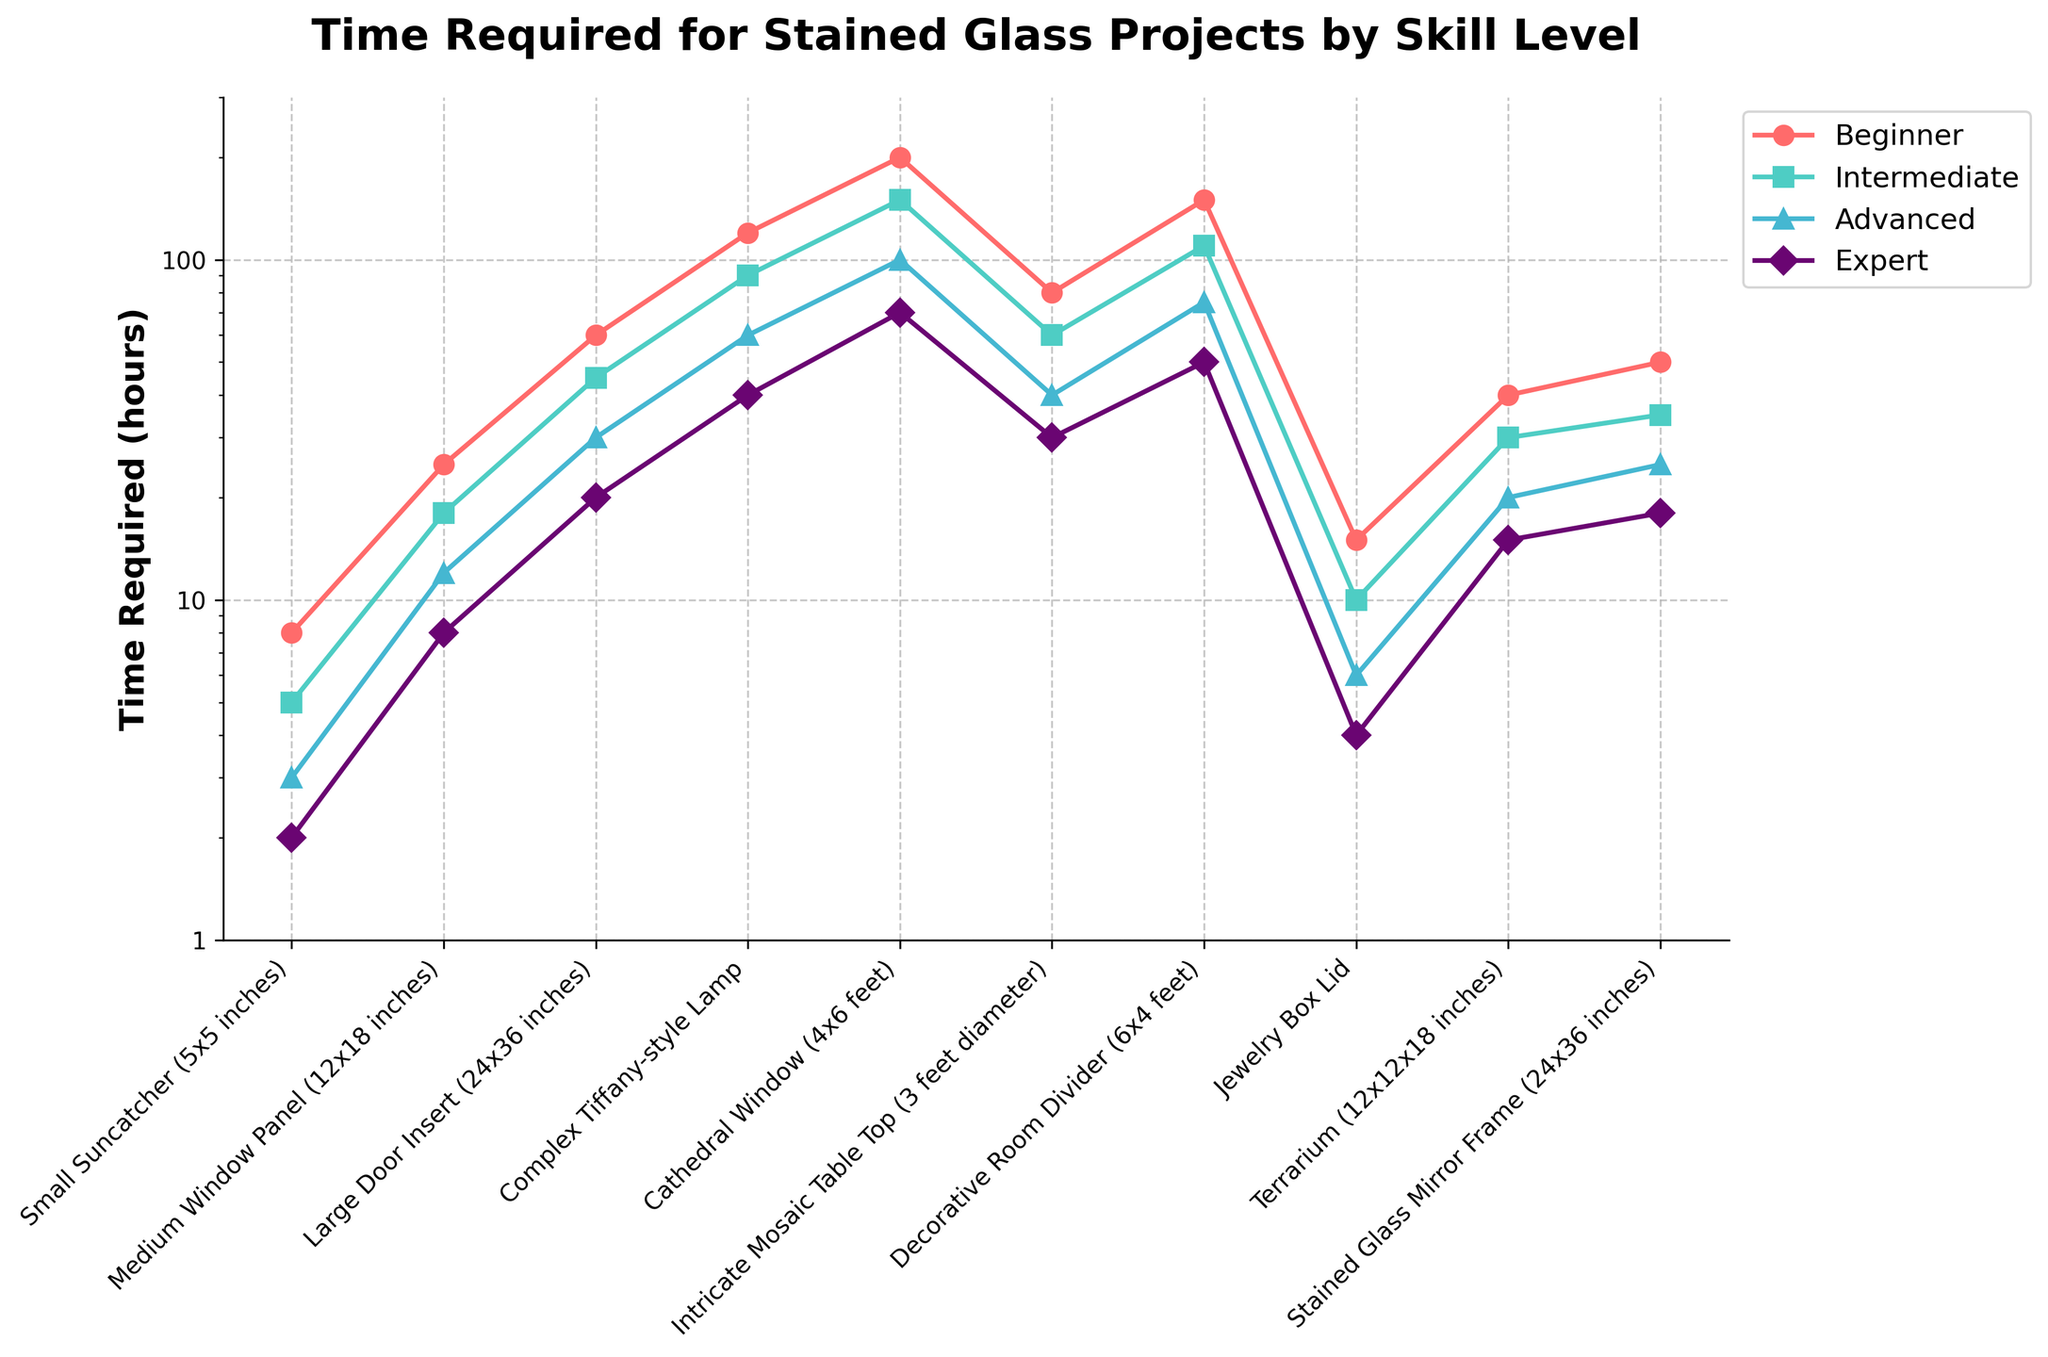What is the difference in time required between a Beginner and an Expert for a Complex Tiffany-style Lamp project? The figure shows the time required for a Complex Tiffany-style Lamp project is 120 hours for a Beginner and 40 hours for an Expert. The difference is 120 - 40 = 80 hours.
Answer: 80 hours Which skill level requires the least amount of time for a Small Suncatcher (5x5 inches) project? The figure shows the time required by each skill level for a Small Suncatcher project. The times are Beginner: 8 hours, Intermediate: 5 hours, Advanced: 3 hours, Expert: 2 hours. The least time required is by the Expert level at 2 hours.
Answer: Expert By what factor does the time required for a Medium Window Panel (12x18 inches) decrease from Beginner to Advanced skill level? The figure shows the time required for a Medium Window Panel project is 25 hours for a Beginner and 12 hours for an Advanced. The factor of decrease is 25 / 12 = approximately 2.08.
Answer: 2.08 For which project size is the relative time savings between Intermediate and Advanced skill levels the greatest? Calculate the difference in time saved from Intermediate to Advanced for each project size and compare. Larger time savings indicate greater relative savings. The significant drop from Intermediate (90 hours) to Advanced (60 hours) for a Complex Tiffany-style Lamp indicates the greatest relative savings at 30 hours.
Answer: Complex Tiffany-style Lamp What is the average time required for an Expert to complete a Large Door Insert (24x36 inches) and a Decorative Room Divider (6x4 feet)? The time required for an Expert to complete a Large Door Insert is 20 hours and for a Decorative Room Divider is 50 hours. The average time is (20 + 50) / 2 = 35 hours.
Answer: 35 hours Which project size shows the smallest difference in time required between Beginner and Intermediate skill levels? Compare the difference in time for each project size between Beginner and Intermediate skill levels. The smallest difference is seen with the Jewelry Box Lid where the difference is 15 - 10 = 5 hours.
Answer: Jewelry Box Lid How does the time required for making a Terrarium (12x12x18 inches) change as one’s skill level progresses from Beginner to Expert? The figure shows the time required for a Terrarium project. The times are Beginner: 40 hours, Intermediate: 30 hours, Advanced: 20 hours, Expert: 15 hours. Progressing from Beginner to Expert, the time decreases as follows: 40 to 30 (10 hours), 30 to 20 (10 hours), 20 to 15 (5 hours).
Answer: Decreases stepwise Which project takes longer for an Intermediate skill level, a Complex Tiffany-style Lamp or a Cathedral Window? According to the figure, the time required for a Complex Tiffany-style Lamp for Intermediate skill level is 90 hours, and for a Cathedral Window is 150 hours. Therefore, the Cathedral Window takes longer.
Answer: Cathedral Window What is the median time required for Advanced skill level across all the projects listed? List the times for Advanced skill level in ascending order: 3, 6, 12, 20, 25, 30, 40, 60, 75, 100. The median value is the average of the 5th and 6th values since there are 10 values: (25+30)/2 = 27.5 hours.
Answer: 27.5 hours 